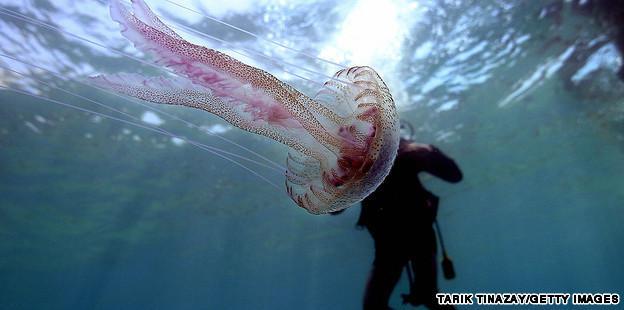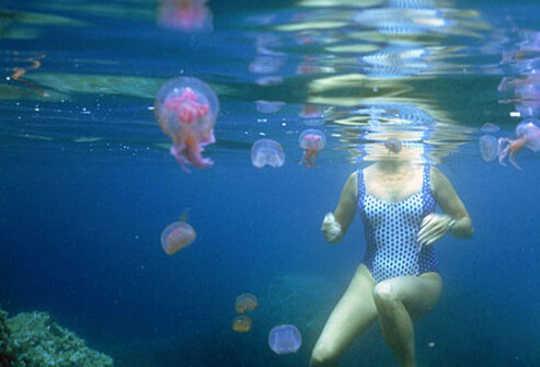The first image is the image on the left, the second image is the image on the right. Evaluate the accuracy of this statement regarding the images: "A woman in a swimsuit is in the water near a jellyfish in the right image, and the left image features one jellyfish with tentacles trailing horizontally.". Is it true? Answer yes or no. Yes. The first image is the image on the left, the second image is the image on the right. Evaluate the accuracy of this statement regarding the images: "A woman in a swimsuit swims in the water near at least one jellyfish in the image on the right.". Is it true? Answer yes or no. Yes. 